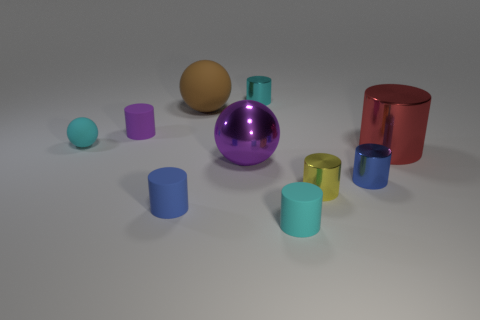Do the objects in the image appear to be arranged in a specific pattern or order? The objects don't seem to follow a specific pattern regarding shape, color, or size arrangement. They are scattered on a flat surface with no discernible pattern, but the arrangement does create a visually pleasant balance between the various shapes and hues. 